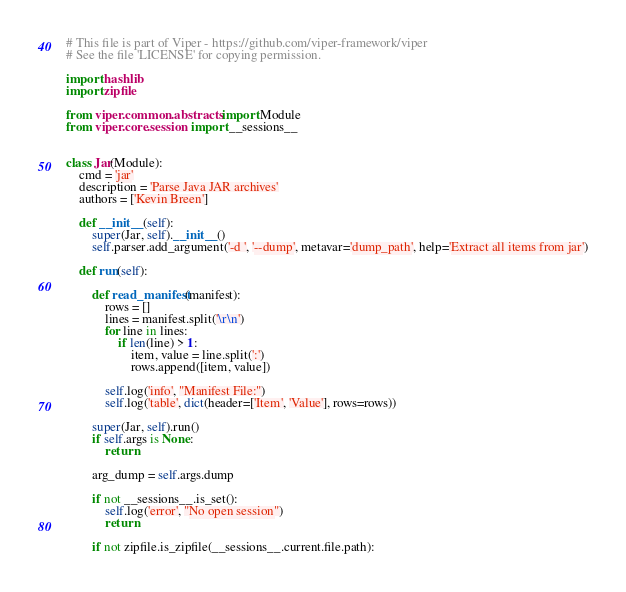<code> <loc_0><loc_0><loc_500><loc_500><_Python_># This file is part of Viper - https://github.com/viper-framework/viper
# See the file 'LICENSE' for copying permission.

import hashlib
import zipfile

from viper.common.abstracts import Module
from viper.core.session import __sessions__


class Jar(Module):
    cmd = 'jar'
    description = 'Parse Java JAR archives'
    authors = ['Kevin Breen']

    def __init__(self):
        super(Jar, self).__init__()
        self.parser.add_argument('-d ', '--dump', metavar='dump_path', help='Extract all items from jar')

    def run(self):

        def read_manifest(manifest):
            rows = []
            lines = manifest.split('\r\n')
            for line in lines:
                if len(line) > 1:
                    item, value = line.split(':')
                    rows.append([item, value])

            self.log('info', "Manifest File:")
            self.log('table', dict(header=['Item', 'Value'], rows=rows))

        super(Jar, self).run()
        if self.args is None:
            return

        arg_dump = self.args.dump

        if not __sessions__.is_set():
            self.log('error', "No open session")
            return

        if not zipfile.is_zipfile(__sessions__.current.file.path):</code> 